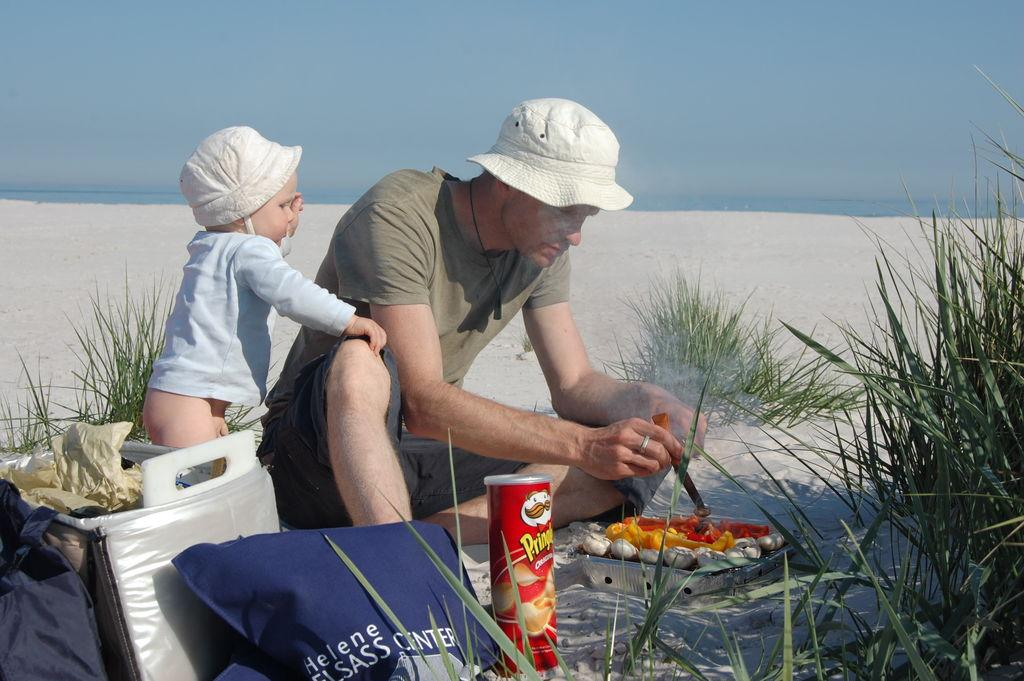What can be seen in the foreground of the image? There are objects and food items in the foreground of the image. How many people are in the foreground of the image? There are two persons in the foreground of the image. What type of surface are the persons standing on? The persons are standing on sand. What can be seen in the background of the image? There is grass, water, and the sky visible in the background of the image. What might be the location of the image based on the background? The image may have been taken on a sandy beach, given the presence of sand and water. What type of books can be seen in the library in the image? There is no library present in the image; it features two persons on sand with food items and objects in the foreground. What act are the persons performing in the image? The image does not depict any specific act or performance; it simply shows two people standing on sand with food items and objects in the foreground. 